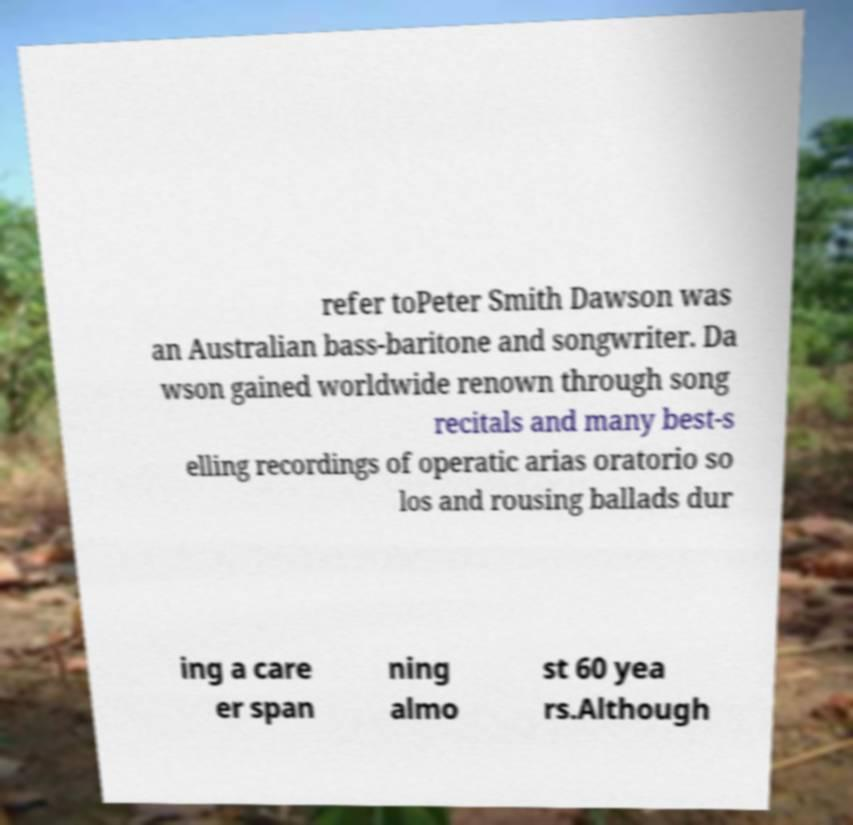Can you accurately transcribe the text from the provided image for me? refer toPeter Smith Dawson was an Australian bass-baritone and songwriter. Da wson gained worldwide renown through song recitals and many best-s elling recordings of operatic arias oratorio so los and rousing ballads dur ing a care er span ning almo st 60 yea rs.Although 